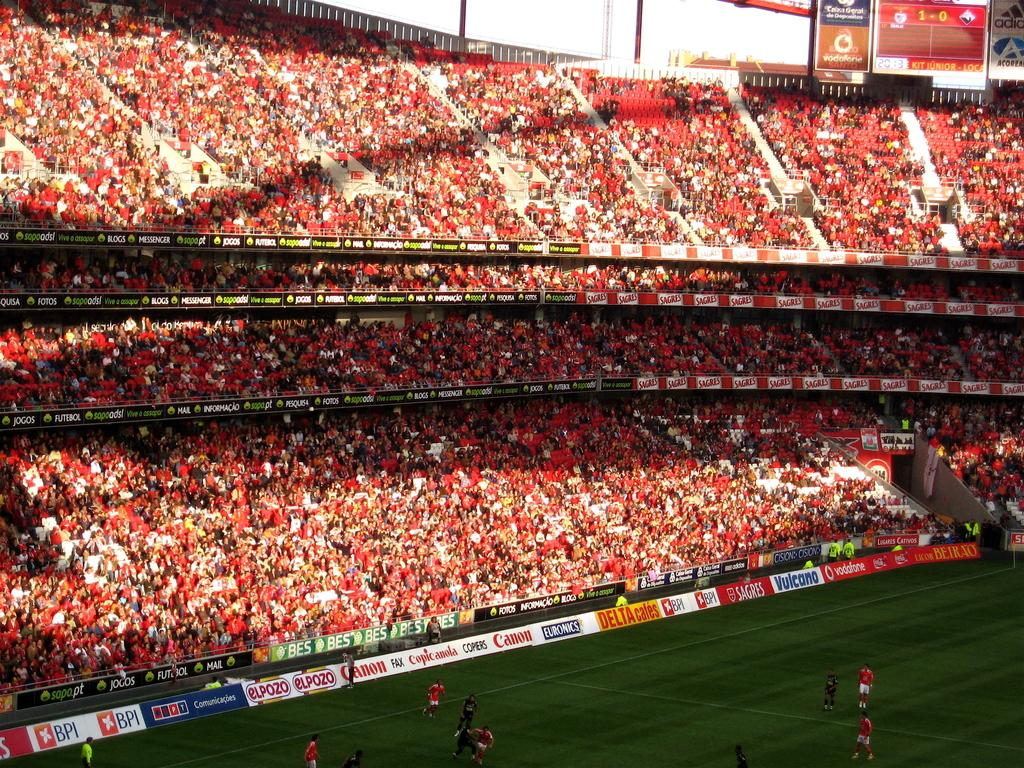<image>
Summarize the visual content of the image. Several ads line a soccer field with one saying DELTA cafes 